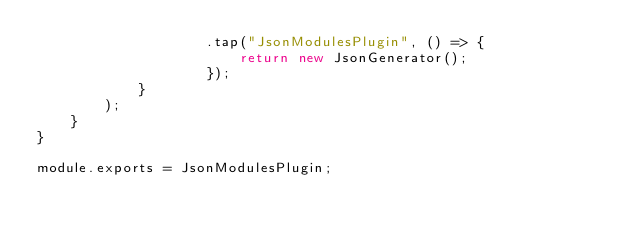Convert code to text. <code><loc_0><loc_0><loc_500><loc_500><_JavaScript_>					.tap("JsonModulesPlugin", () => {
						return new JsonGenerator();
					});
			}
		);
	}
}

module.exports = JsonModulesPlugin;
</code> 